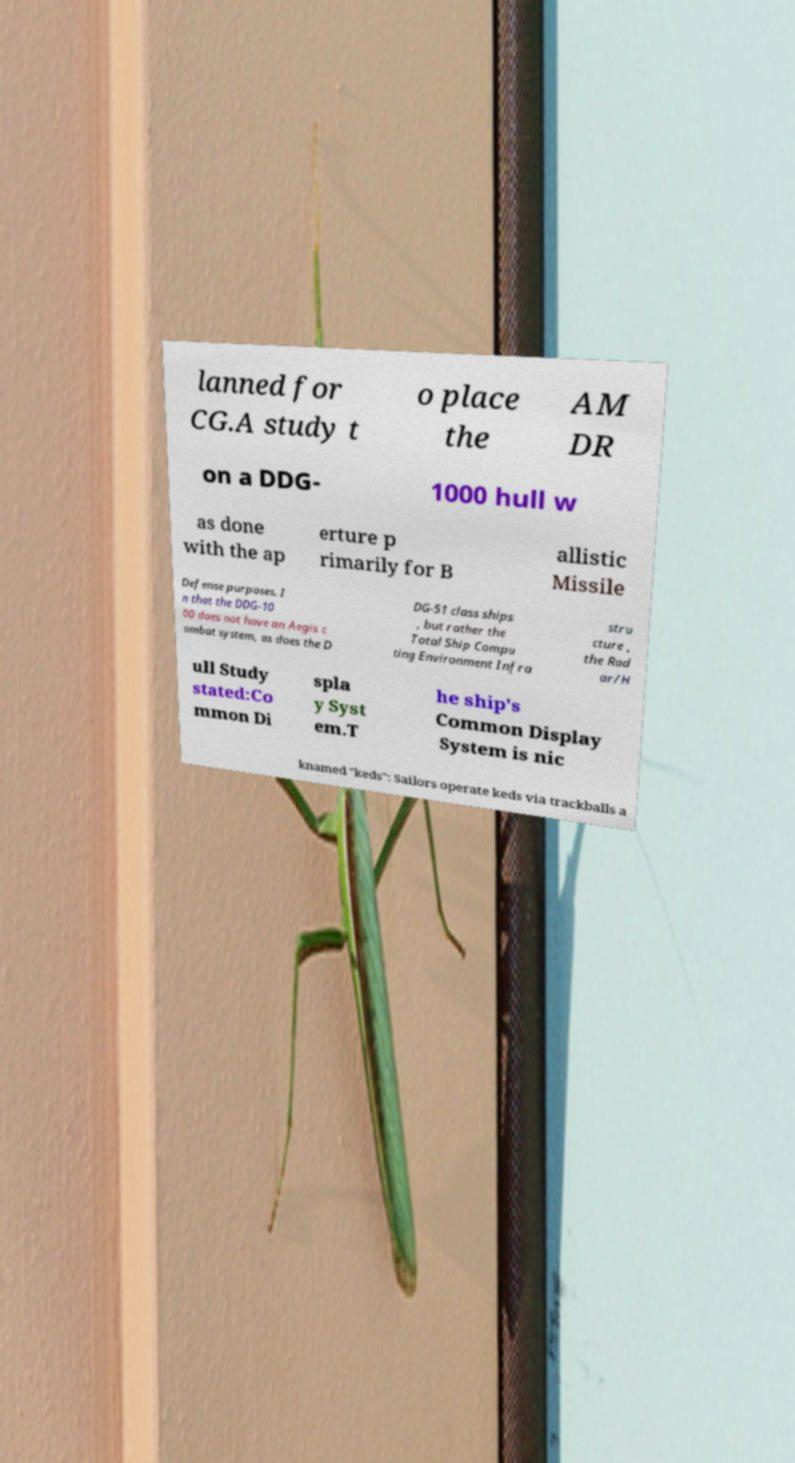Can you read and provide the text displayed in the image?This photo seems to have some interesting text. Can you extract and type it out for me? lanned for CG.A study t o place the AM DR on a DDG- 1000 hull w as done with the ap erture p rimarily for B allistic Missile Defense purposes. I n that the DDG-10 00 does not have an Aegis c ombat system, as does the D DG-51 class ships , but rather the Total Ship Compu ting Environment Infra stru cture , the Rad ar/H ull Study stated:Co mmon Di spla y Syst em.T he ship's Common Display System is nic knamed "keds": Sailors operate keds via trackballs a 